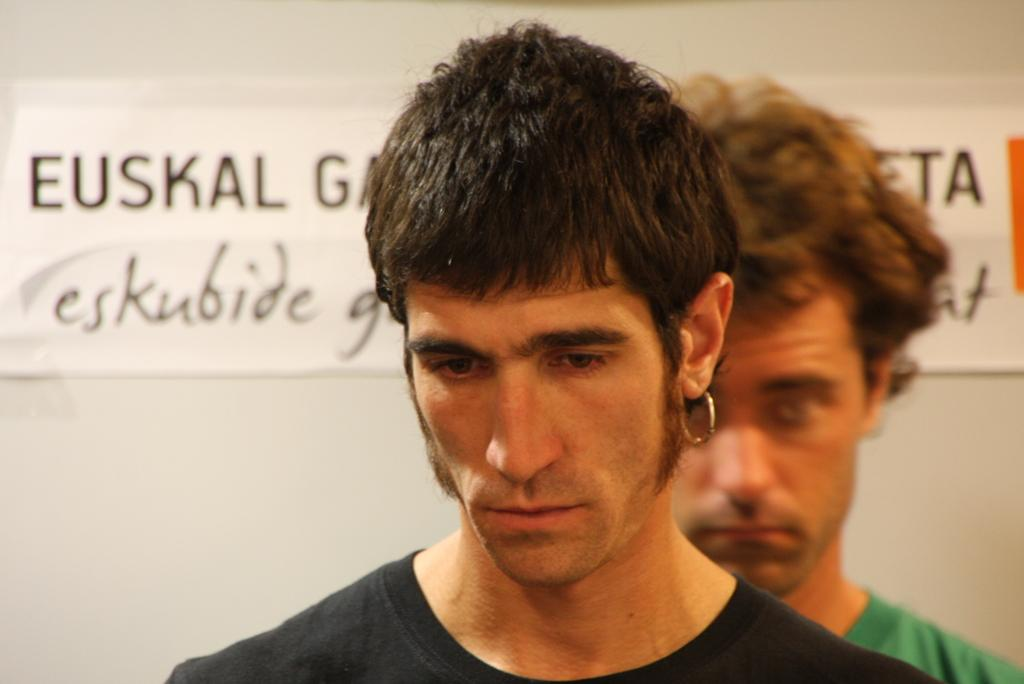How many people are in the image? There are two persons in the image. What are the persons wearing? The persons are wearing t-shirts. What can be seen on the wall in the background? There are text papers attached to a plain wall in the background. Is there any quicksand visible in the image? No, there is no quicksand present in the image. How do the persons in the image exhibit harmony? The image does not provide information about the behavior or harmony between the persons. 